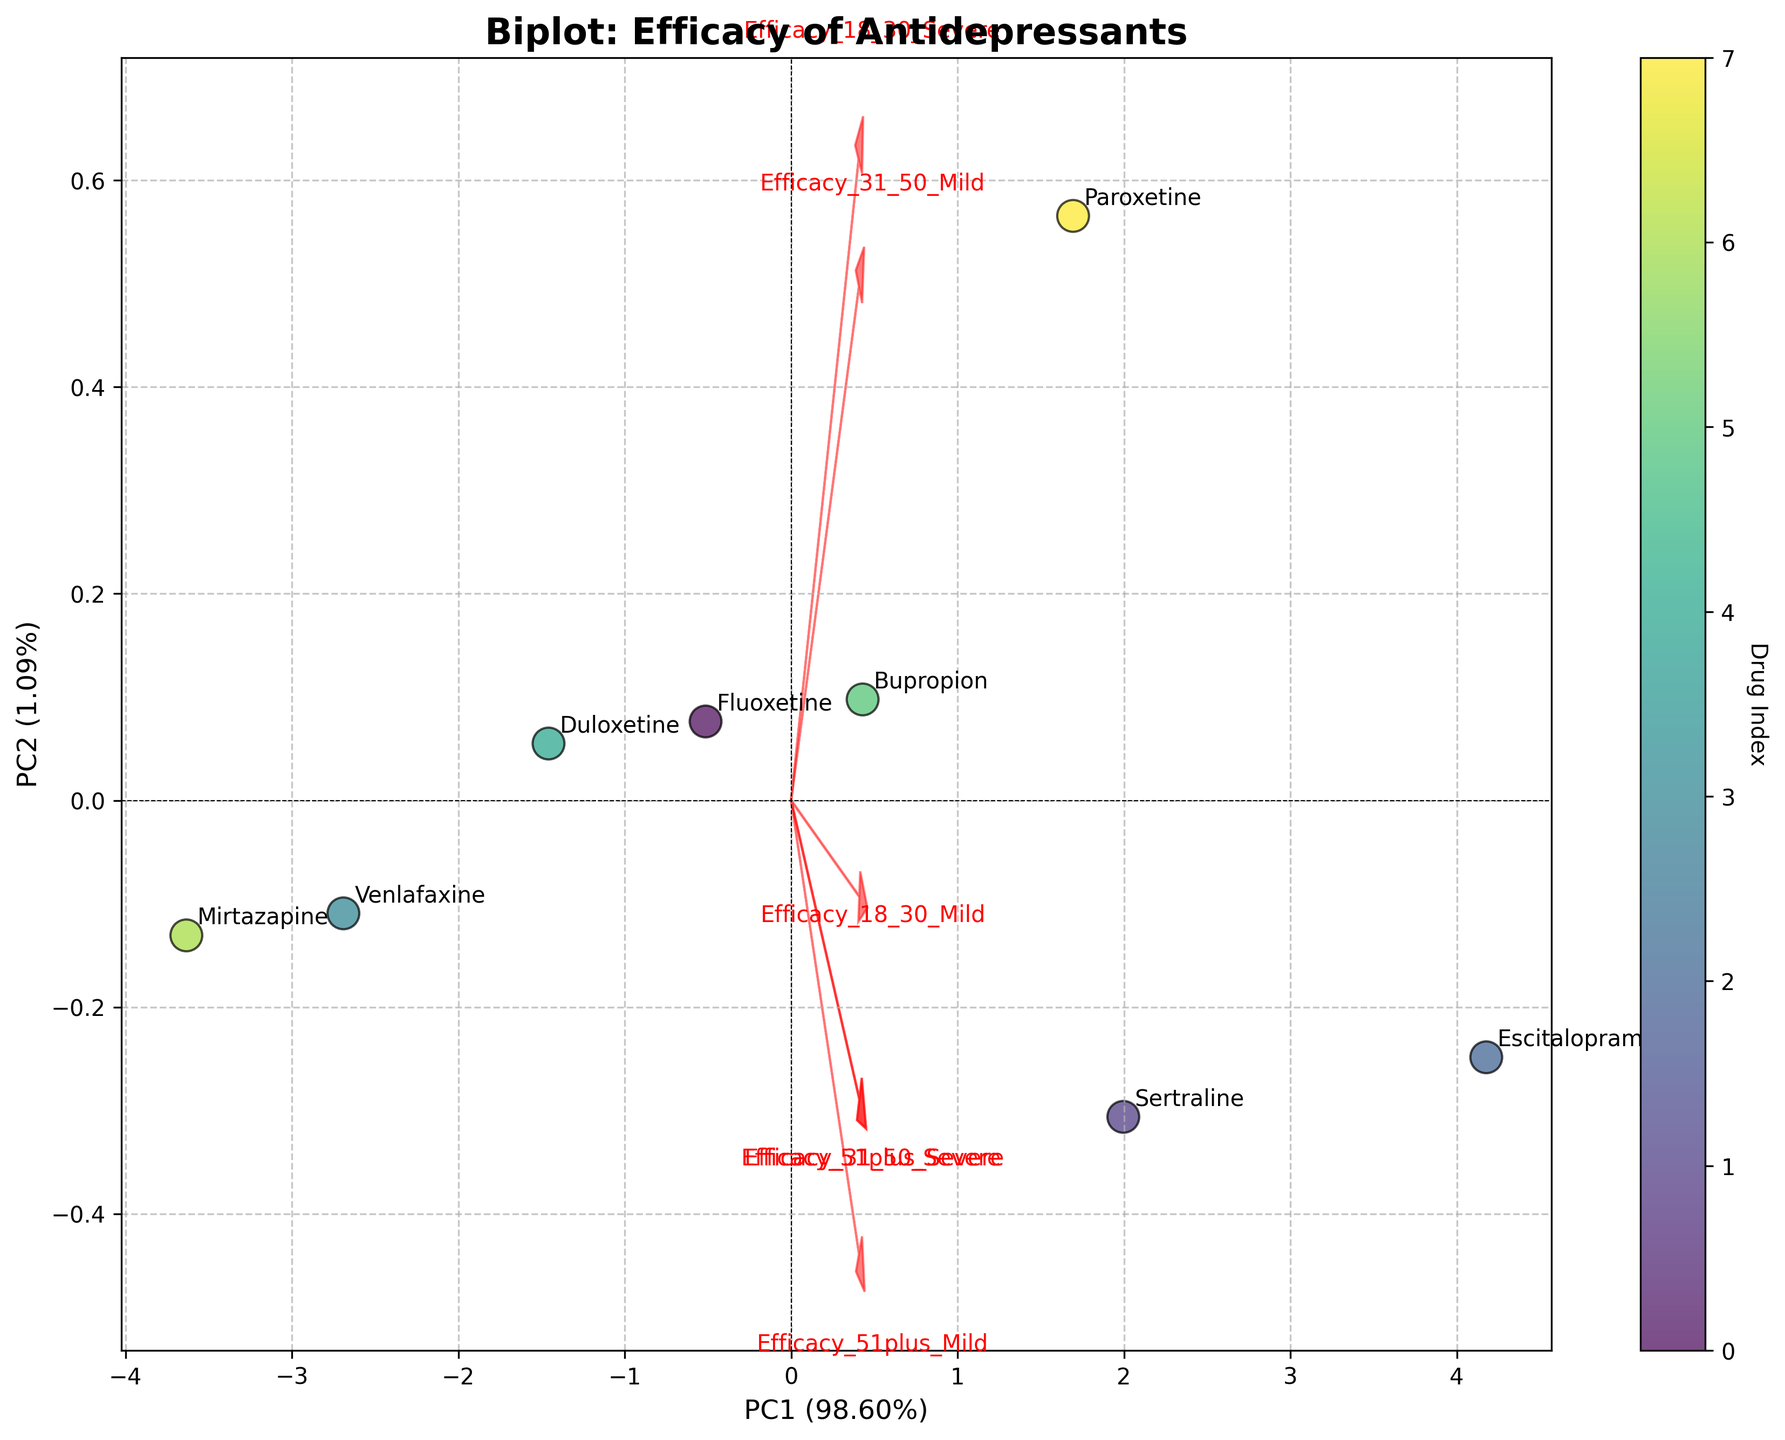What is the title of the figure? The title is usually located at the top of the figure. It summarizes the content being presented. In this case, the title is 'Biplot: Efficacy of Antidepressants', which indicates that the figure shows a biplot comparing the efficacy of various antidepressants.
Answer: Biplot: Efficacy of Antidepressants How many antidepressants are compared in the biplot? By counting the annotated labels on the scatter plot, we can determine the number of antidepressants compared. There are eight labels corresponding to eight antidepressants.
Answer: Eight Which antidepressants have the highest efficacy for the 18-30 age group with severe depression? To find this, look at the label positions and check the loading vectors for 'Efficacy_18_30_Severe'. The labels closest to the vector indicate higher efficacy. Escitalopram and Sertraline are closest and appear to have the highest efficacy for this subgroup.
Answer: Escitalopram and Sertraline What percentage of the total variance is explained by the first principal component (PC1)? The x-axis label, 'PC1', also includes the explained variance percentage. The percentage of variance explained by PC1 is given directly in the label. It is 52%.
Answer: 52% Are any antidepressants close to the origin? Observing the plot, we need to find if any points (representing antidepressants) are near the coordinates (0, 0). Mirtazapine appears relatively close to the origin compared to others.
Answer: Mirtazapine Which efficacy measure contributes more positively to PC2, 'Efficacy_51plus_Mild' or 'Efficacy_51plus_Severe'? By examining the direction and length of the loading vectors (red arrows) corresponding to 'Efficacy_51plus_Mild' and 'Efficacy_51plus_Severe', the one extending more significantly along the PC2 axis contributes more positively. 'Efficacy_51plus_Mild' contributes more positively to PC2.
Answer: 'Efficacy_51plus_Mild' How does Fluoxetine compare to Paroxetine in participants aged 31-50 with severe depression? To answer this, compare the labeled points for Fluoxetine and Paroxetine, and check the direction and magnitude of the loading vector for 'Efficacy_31_50_Severe'. Paroxetine is positioned further in the direction of the vector, indicating higher efficacy.
Answer: Paroxetine What is the cumulative variance explained by both principal components? The cumulative variance is the sum of the percentages of variance explained by PC1 and PC2. According to the axis labels, PC1 explains 52% and PC2 explains 23% of the variance. Summing these gives 75%.
Answer: 75% Which drug shows the least efficacy for participants aged 51 and older with severe depression? Look at the proximity of the drug labels to the 'Efficacy_51plus_Severe' vector. The drug farthest from the direction of this vector likely shows the least efficacy. Mirtazapine is the farthest from the vector.
Answer: Mirtazapine 